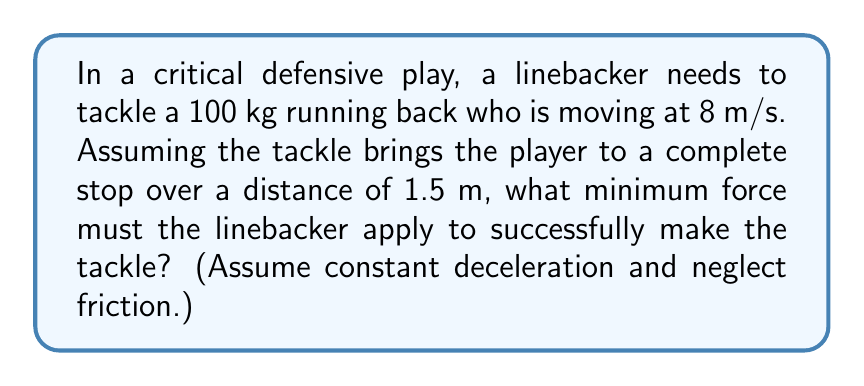Provide a solution to this math problem. To solve this problem, we'll use Newton's Second Law of Motion and the concept of work-energy theorem. Let's break it down step-by-step:

1) First, we need to find the deceleration of the running back. We can use the equation of motion:

   $v^2 = u^2 + 2as$

   Where:
   $v$ = final velocity (0 m/s)
   $u$ = initial velocity (8 m/s)
   $s$ = stopping distance (1.5 m)
   $a$ = deceleration (unknown)

2) Substituting the values:

   $0^2 = 8^2 + 2a(1.5)$
   $0 = 64 + 3a$
   $a = -21.33$ m/s²

3) Now that we have the deceleration, we can use Newton's Second Law:

   $F = ma$

   Where:
   $m$ = mass of the running back (100 kg)
   $a$ = deceleration (-21.33 m/s²)

4) Substituting these values:

   $F = 100 \times (-21.33) = -2133$ N

5) The negative sign indicates the force is in the opposite direction of the running back's motion. The magnitude of the force is 2133 N.

This is the minimum force required to bring the player to a stop over 1.5 m. In a real tackle, the linebacker would likely apply a greater force to ensure a successful stop.
Answer: 2133 N 